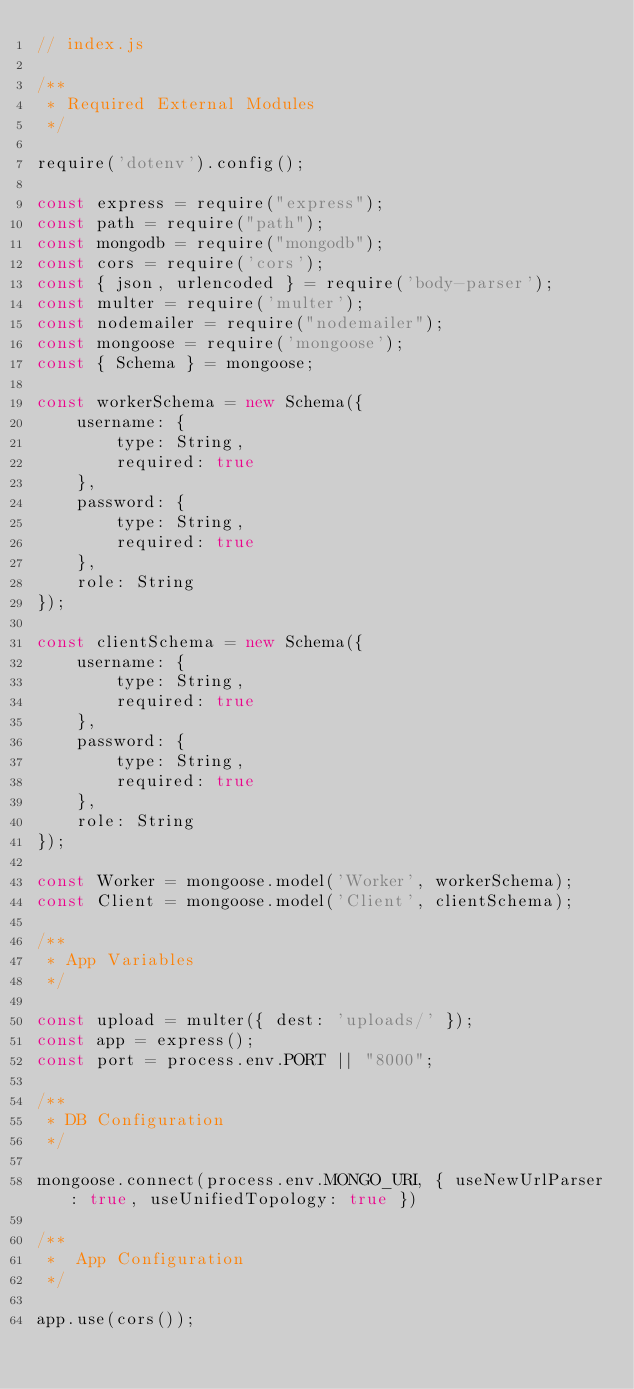<code> <loc_0><loc_0><loc_500><loc_500><_JavaScript_>// index.js

/**
 * Required External Modules
 */

require('dotenv').config();

const express = require("express");
const path = require("path");
const mongodb = require("mongodb");
const cors = require('cors');
const { json, urlencoded } = require('body-parser');
const multer = require('multer');
const nodemailer = require("nodemailer");
const mongoose = require('mongoose');
const { Schema } = mongoose;

const workerSchema = new Schema({
    username: {
        type: String,
        required: true
    },
    password: {
        type: String,
        required: true
    },
    role: String
});

const clientSchema = new Schema({
    username: {
        type: String,
        required: true
    },
    password: {
        type: String,
        required: true
    },
    role: String
});

const Worker = mongoose.model('Worker', workerSchema);
const Client = mongoose.model('Client', clientSchema);

/**
 * App Variables
 */

const upload = multer({ dest: 'uploads/' });
const app = express();
const port = process.env.PORT || "8000";

/**
 * DB Configuration
 */

mongoose.connect(process.env.MONGO_URI, { useNewUrlParser: true, useUnifiedTopology: true })

/**
 *  App Configuration
 */

app.use(cors());</code> 